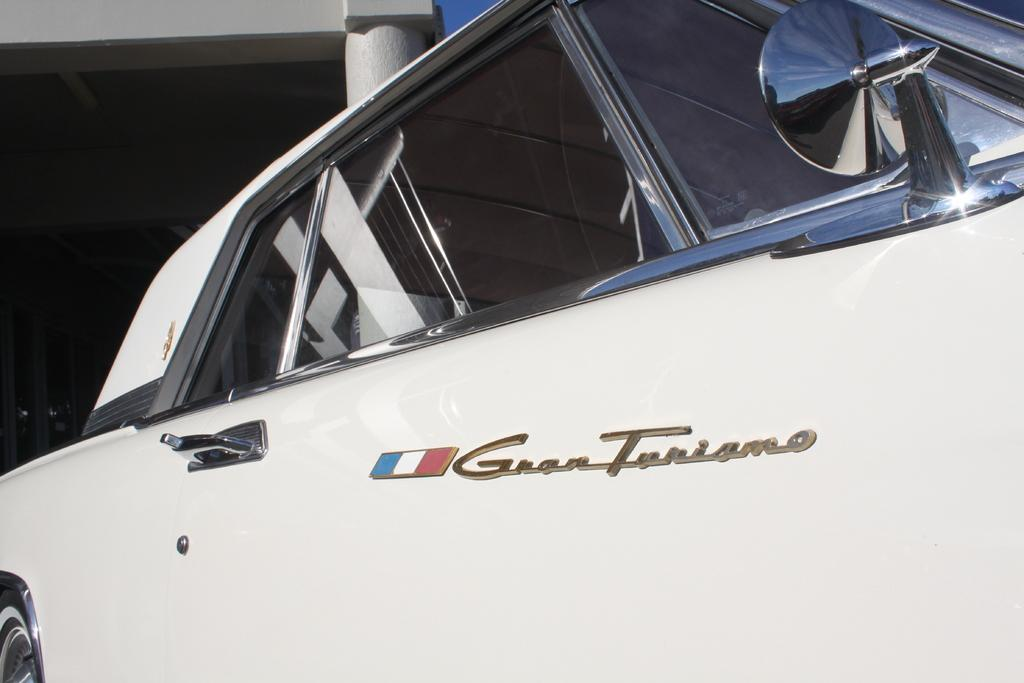What type of vehicle is present in the image? There is a motor vehicle in the image. How many teeth can be seen on the hill in the image? There is no hill or teeth present in the image; it only features a motor vehicle. 